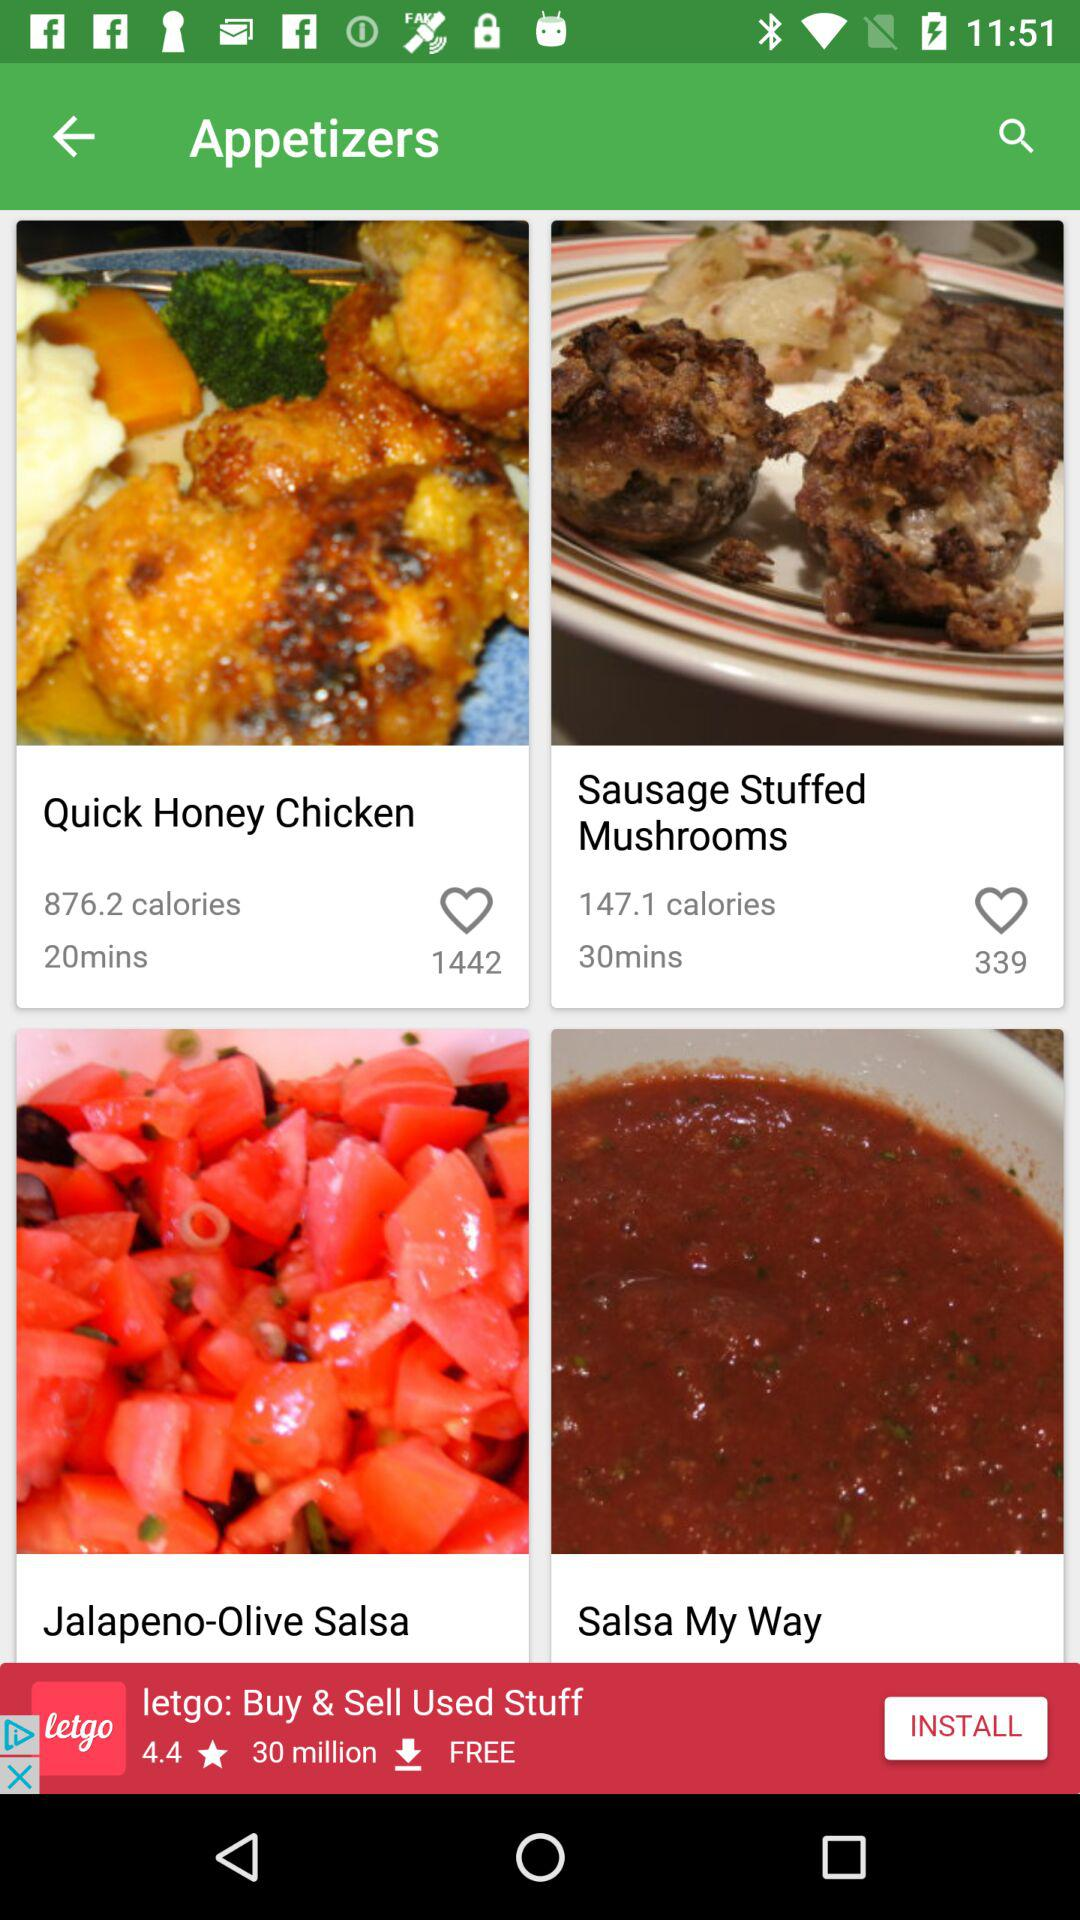Sausage Stuffed Mushrooms have how many likes? Sausage Stuffed Mushrooms have 339 likes. 